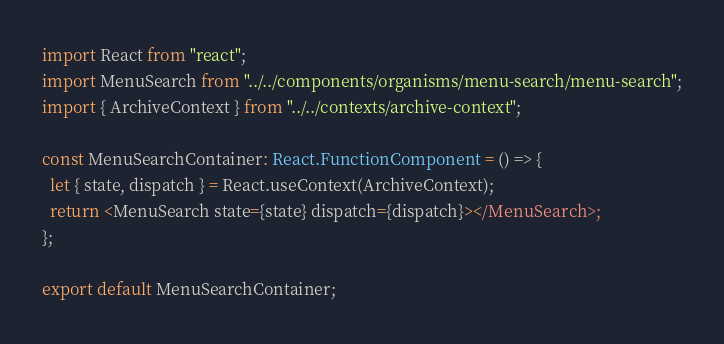Convert code to text. <code><loc_0><loc_0><loc_500><loc_500><_TypeScript_>import React from "react";
import MenuSearch from "../../components/organisms/menu-search/menu-search";
import { ArchiveContext } from "../../contexts/archive-context";

const MenuSearchContainer: React.FunctionComponent = () => {
  let { state, dispatch } = React.useContext(ArchiveContext);
  return <MenuSearch state={state} dispatch={dispatch}></MenuSearch>;
};

export default MenuSearchContainer;
</code> 